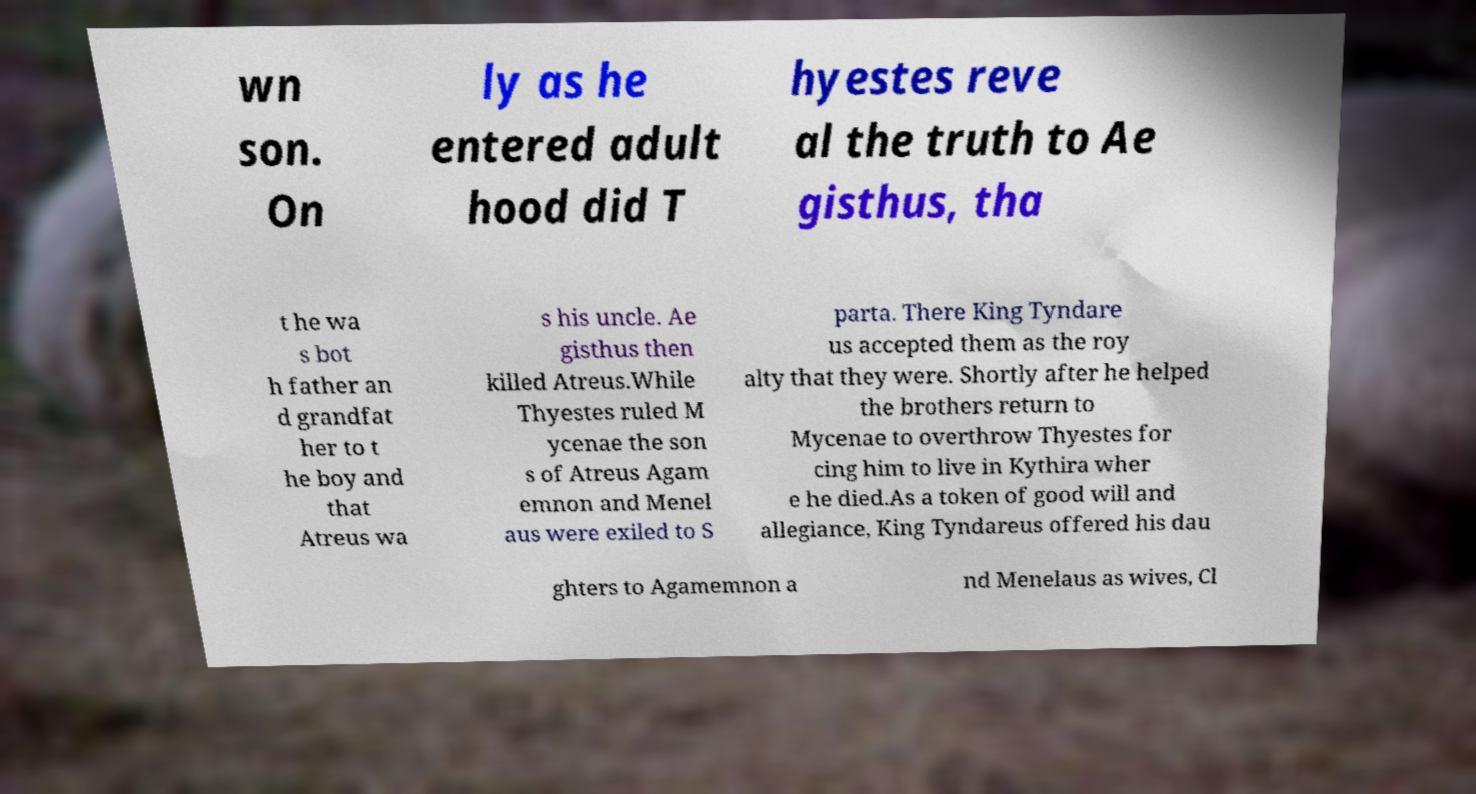I need the written content from this picture converted into text. Can you do that? wn son. On ly as he entered adult hood did T hyestes reve al the truth to Ae gisthus, tha t he wa s bot h father an d grandfat her to t he boy and that Atreus wa s his uncle. Ae gisthus then killed Atreus.While Thyestes ruled M ycenae the son s of Atreus Agam emnon and Menel aus were exiled to S parta. There King Tyndare us accepted them as the roy alty that they were. Shortly after he helped the brothers return to Mycenae to overthrow Thyestes for cing him to live in Kythira wher e he died.As a token of good will and allegiance, King Tyndareus offered his dau ghters to Agamemnon a nd Menelaus as wives, Cl 